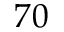<formula> <loc_0><loc_0><loc_500><loc_500>7 0</formula> 